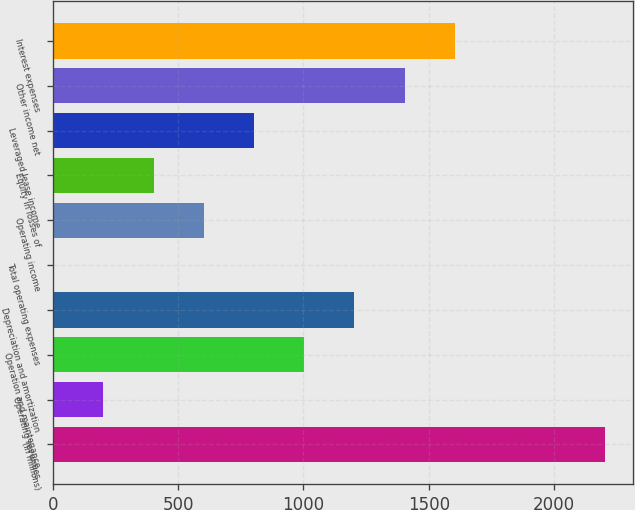<chart> <loc_0><loc_0><loc_500><loc_500><bar_chart><fcel>(in millions)<fcel>Operating revenues<fcel>Operation and maintenance<fcel>Depreciation and amortization<fcel>Total operating expenses<fcel>Operating income<fcel>Equity in losses of<fcel>Leveraged lease income<fcel>Other income net<fcel>Interest expenses<nl><fcel>2204.3<fcel>201.3<fcel>1002.5<fcel>1202.8<fcel>1<fcel>601.9<fcel>401.6<fcel>802.2<fcel>1403.1<fcel>1603.4<nl></chart> 